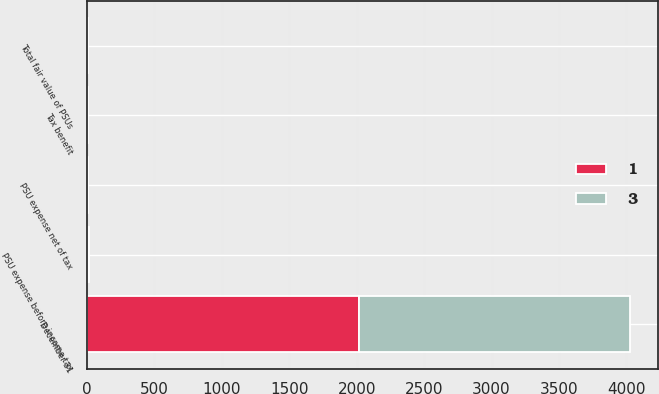<chart> <loc_0><loc_0><loc_500><loc_500><stacked_bar_chart><ecel><fcel>December 31<fcel>PSU expense before income tax<fcel>Tax benefit<fcel>PSU expense net of tax<fcel>Total fair value of PSUs<nl><fcel>1<fcel>2016<fcel>6<fcel>2<fcel>4<fcel>3<nl><fcel>3<fcel>2014<fcel>6<fcel>2<fcel>4<fcel>1<nl></chart> 